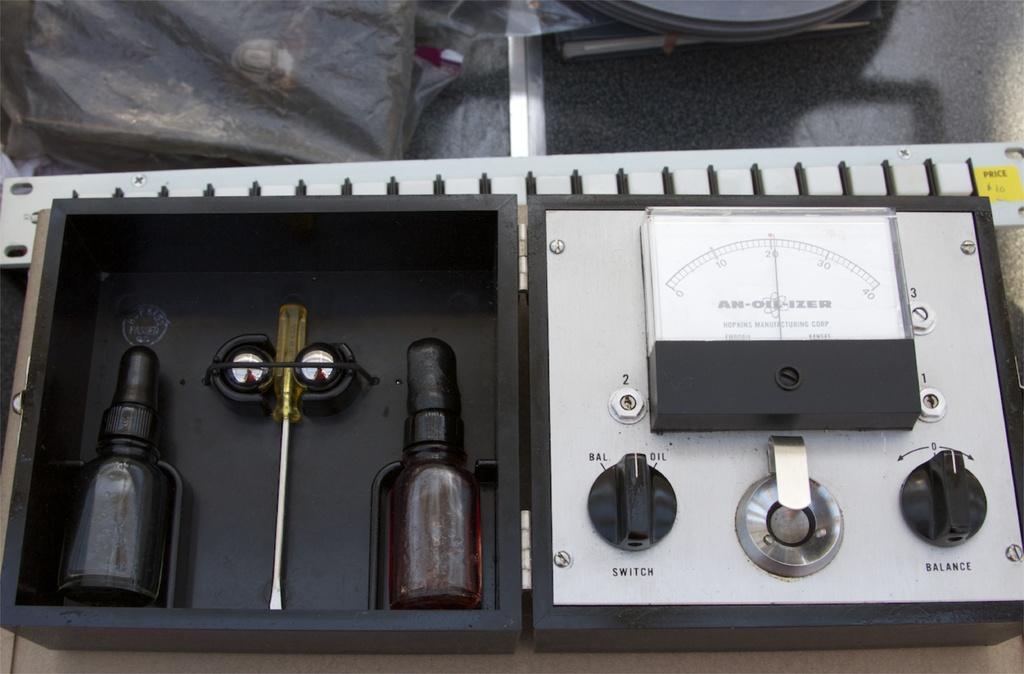Describe this image in one or two sentences. In this picture we can observe a device which is in white and black color. On the left side we can observe two bottles placed in the box. We can observe a screwdriver which is in yellow color placed in this box. 